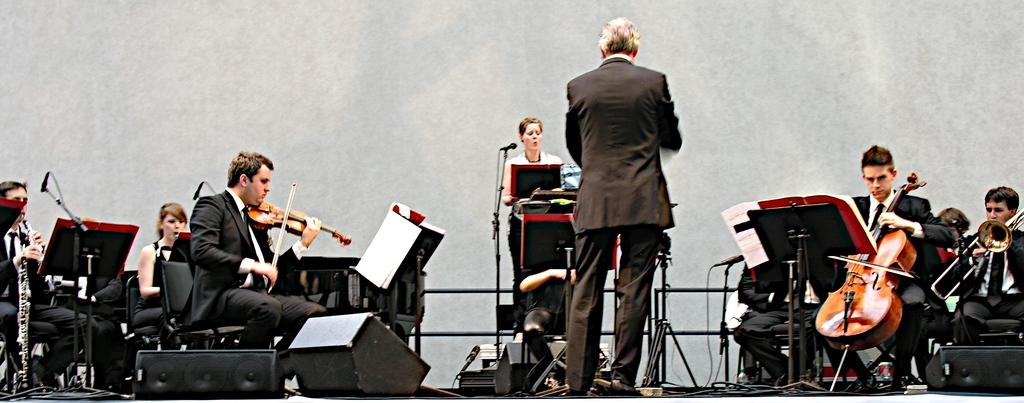What are the people in the image doing? The people in the image are sitting and playing musical instruments. What else can be seen in the image besides the people playing instruments? There is a paper in the image. Are there any individuals standing in the image? Yes, a woman and a man are standing in the middle of the image. What direction are the people sleeping in the image? There is no one sleeping in the image; the people are playing musical instruments. What type of alarm is present in the image? There is no alarm present in the image. 